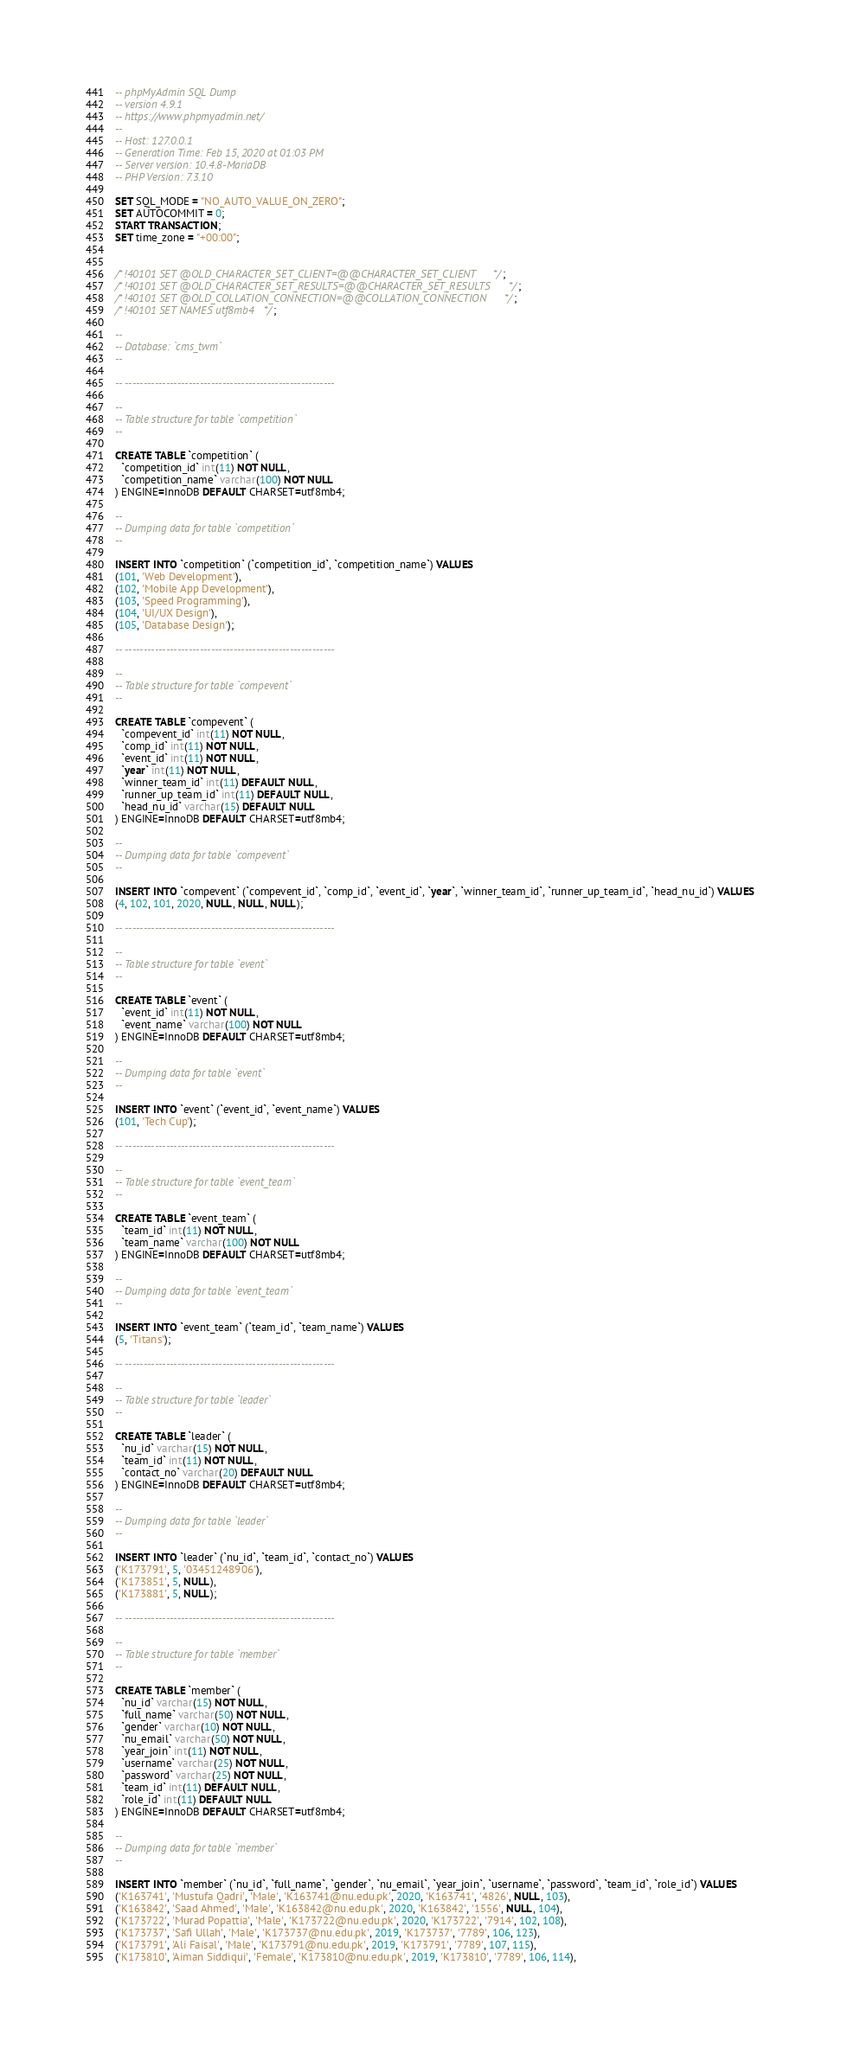<code> <loc_0><loc_0><loc_500><loc_500><_SQL_>-- phpMyAdmin SQL Dump
-- version 4.9.1
-- https://www.phpmyadmin.net/
--
-- Host: 127.0.0.1
-- Generation Time: Feb 15, 2020 at 01:03 PM
-- Server version: 10.4.8-MariaDB
-- PHP Version: 7.3.10

SET SQL_MODE = "NO_AUTO_VALUE_ON_ZERO";
SET AUTOCOMMIT = 0;
START TRANSACTION;
SET time_zone = "+00:00";


/*!40101 SET @OLD_CHARACTER_SET_CLIENT=@@CHARACTER_SET_CLIENT */;
/*!40101 SET @OLD_CHARACTER_SET_RESULTS=@@CHARACTER_SET_RESULTS */;
/*!40101 SET @OLD_COLLATION_CONNECTION=@@COLLATION_CONNECTION */;
/*!40101 SET NAMES utf8mb4 */;

--
-- Database: `cms_twm`
--

-- --------------------------------------------------------

--
-- Table structure for table `competition`
--

CREATE TABLE `competition` (
  `competition_id` int(11) NOT NULL,
  `competition_name` varchar(100) NOT NULL
) ENGINE=InnoDB DEFAULT CHARSET=utf8mb4;

--
-- Dumping data for table `competition`
--

INSERT INTO `competition` (`competition_id`, `competition_name`) VALUES
(101, 'Web Development'),
(102, 'Mobile App Development'),
(103, 'Speed Programming'),
(104, 'UI/UX Design'),
(105, 'Database Design');

-- --------------------------------------------------------

--
-- Table structure for table `compevent`
--

CREATE TABLE `compevent` (
  `compevent_id` int(11) NOT NULL,
  `comp_id` int(11) NOT NULL,
  `event_id` int(11) NOT NULL,
  `year` int(11) NOT NULL,
  `winner_team_id` int(11) DEFAULT NULL,
  `runner_up_team_id` int(11) DEFAULT NULL,
  `head_nu_id` varchar(15) DEFAULT NULL
) ENGINE=InnoDB DEFAULT CHARSET=utf8mb4;

--
-- Dumping data for table `compevent`
--

INSERT INTO `compevent` (`compevent_id`, `comp_id`, `event_id`, `year`, `winner_team_id`, `runner_up_team_id`, `head_nu_id`) VALUES
(4, 102, 101, 2020, NULL, NULL, NULL);

-- --------------------------------------------------------

--
-- Table structure for table `event`
--

CREATE TABLE `event` (
  `event_id` int(11) NOT NULL,
  `event_name` varchar(100) NOT NULL
) ENGINE=InnoDB DEFAULT CHARSET=utf8mb4;

--
-- Dumping data for table `event`
--

INSERT INTO `event` (`event_id`, `event_name`) VALUES
(101, 'Tech Cup');

-- --------------------------------------------------------

--
-- Table structure for table `event_team`
--

CREATE TABLE `event_team` (
  `team_id` int(11) NOT NULL,
  `team_name` varchar(100) NOT NULL
) ENGINE=InnoDB DEFAULT CHARSET=utf8mb4;

--
-- Dumping data for table `event_team`
--

INSERT INTO `event_team` (`team_id`, `team_name`) VALUES
(5, 'Titans');

-- --------------------------------------------------------

--
-- Table structure for table `leader`
--

CREATE TABLE `leader` (
  `nu_id` varchar(15) NOT NULL,
  `team_id` int(11) NOT NULL,
  `contact_no` varchar(20) DEFAULT NULL
) ENGINE=InnoDB DEFAULT CHARSET=utf8mb4;

--
-- Dumping data for table `leader`
--

INSERT INTO `leader` (`nu_id`, `team_id`, `contact_no`) VALUES
('K173791', 5, '03451248906'),
('K173851', 5, NULL),
('K173881', 5, NULL);

-- --------------------------------------------------------

--
-- Table structure for table `member`
--

CREATE TABLE `member` (
  `nu_id` varchar(15) NOT NULL,
  `full_name` varchar(50) NOT NULL,
  `gender` varchar(10) NOT NULL,
  `nu_email` varchar(50) NOT NULL,
  `year_join` int(11) NOT NULL,
  `username` varchar(25) NOT NULL,
  `password` varchar(25) NOT NULL,
  `team_id` int(11) DEFAULT NULL,
  `role_id` int(11) DEFAULT NULL
) ENGINE=InnoDB DEFAULT CHARSET=utf8mb4;

--
-- Dumping data for table `member`
--

INSERT INTO `member` (`nu_id`, `full_name`, `gender`, `nu_email`, `year_join`, `username`, `password`, `team_id`, `role_id`) VALUES
('K163741', 'Mustufa Qadri', 'Male', 'K163741@nu.edu.pk', 2020, 'K163741', '4826', NULL, 103),
('K163842', 'Saad Ahmed', 'Male', 'K163842@nu.edu.pk', 2020, 'K163842', '1556', NULL, 104),
('K173722', 'Murad Popattia', 'Male', 'K173722@nu.edu.pk', 2020, 'K173722', '7914', 102, 108),
('K173737', 'Safi Ullah', 'Male', 'K173737@nu.edu.pk', 2019, 'K173737', '7789', 106, 123),
('K173791', 'Ali Faisal', 'Male', 'K173791@nu.edu.pk', 2019, 'K173791', '7789', 107, 115),
('K173810', 'Aiman Siddiqui', 'Female', 'K173810@nu.edu.pk', 2019, 'K173810', '7789', 106, 114),</code> 